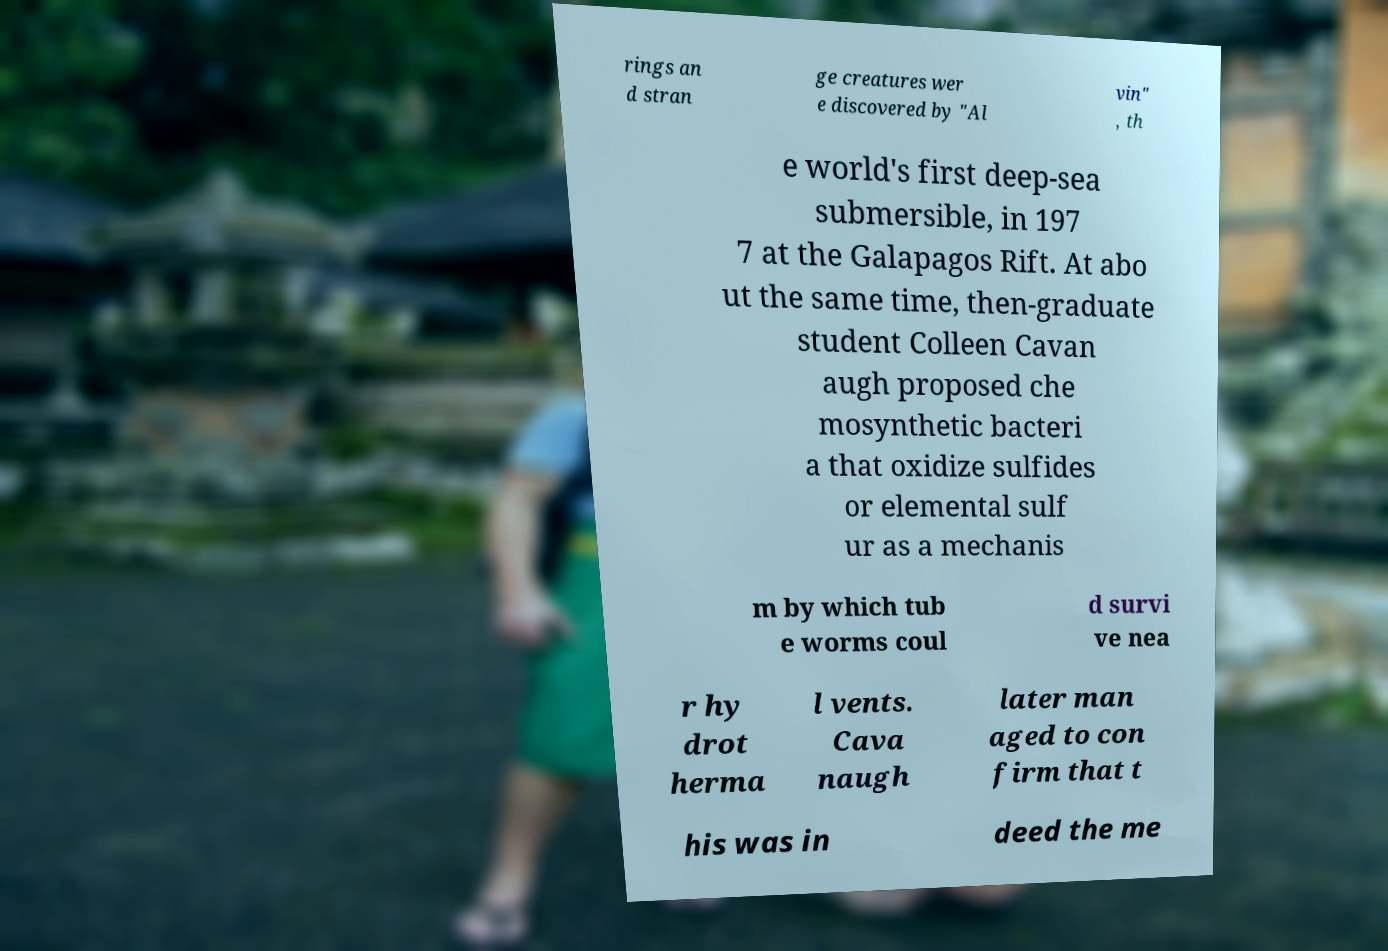Can you accurately transcribe the text from the provided image for me? rings an d stran ge creatures wer e discovered by "Al vin" , th e world's first deep-sea submersible, in 197 7 at the Galapagos Rift. At abo ut the same time, then-graduate student Colleen Cavan augh proposed che mosynthetic bacteri a that oxidize sulfides or elemental sulf ur as a mechanis m by which tub e worms coul d survi ve nea r hy drot herma l vents. Cava naugh later man aged to con firm that t his was in deed the me 